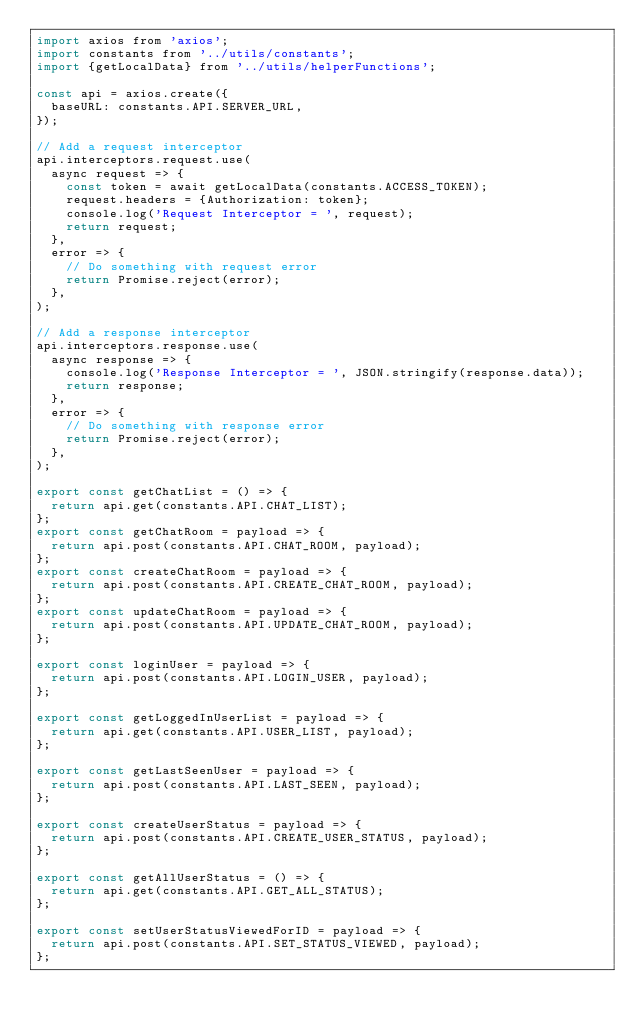Convert code to text. <code><loc_0><loc_0><loc_500><loc_500><_JavaScript_>import axios from 'axios';
import constants from '../utils/constants';
import {getLocalData} from '../utils/helperFunctions';

const api = axios.create({
  baseURL: constants.API.SERVER_URL,
});

// Add a request interceptor
api.interceptors.request.use(
  async request => {
    const token = await getLocalData(constants.ACCESS_TOKEN);
    request.headers = {Authorization: token};
    console.log('Request Interceptor = ', request);
    return request;
  },
  error => {
    // Do something with request error
    return Promise.reject(error);
  },
);

// Add a response interceptor
api.interceptors.response.use(
  async response => {
    console.log('Response Interceptor = ', JSON.stringify(response.data));
    return response;
  },
  error => {
    // Do something with response error
    return Promise.reject(error);
  },
);

export const getChatList = () => {
  return api.get(constants.API.CHAT_LIST);
};
export const getChatRoom = payload => {
  return api.post(constants.API.CHAT_ROOM, payload);
};
export const createChatRoom = payload => {
  return api.post(constants.API.CREATE_CHAT_ROOM, payload);
};
export const updateChatRoom = payload => {
  return api.post(constants.API.UPDATE_CHAT_ROOM, payload);
};

export const loginUser = payload => {
  return api.post(constants.API.LOGIN_USER, payload);
};

export const getLoggedInUserList = payload => {
  return api.get(constants.API.USER_LIST, payload);
};

export const getLastSeenUser = payload => {
  return api.post(constants.API.LAST_SEEN, payload);
};

export const createUserStatus = payload => {
  return api.post(constants.API.CREATE_USER_STATUS, payload);
};

export const getAllUserStatus = () => {
  return api.get(constants.API.GET_ALL_STATUS);
};

export const setUserStatusViewedForID = payload => {
  return api.post(constants.API.SET_STATUS_VIEWED, payload);
};
</code> 